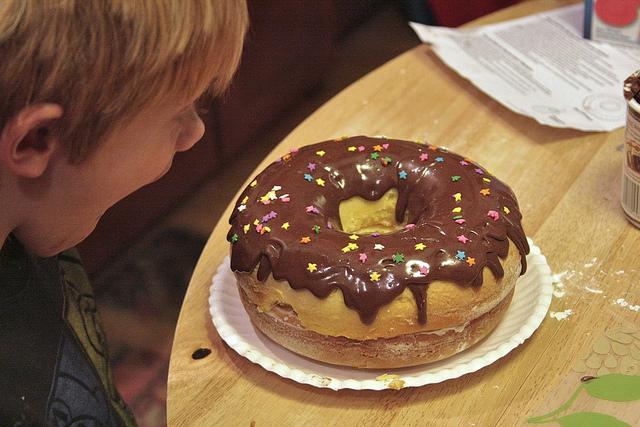What is the cake made to look like?
Concise answer only. Donut. What color is the icing?
Keep it brief. Brown. What kind of desert is shown?
Answer briefly. Cake. 